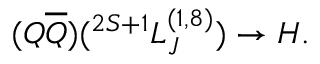<formula> <loc_0><loc_0><loc_500><loc_500>( Q \overline { Q } ) ( ^ { 2 S + 1 } L _ { J } ^ { ( 1 , 8 ) } ) \to H .</formula> 